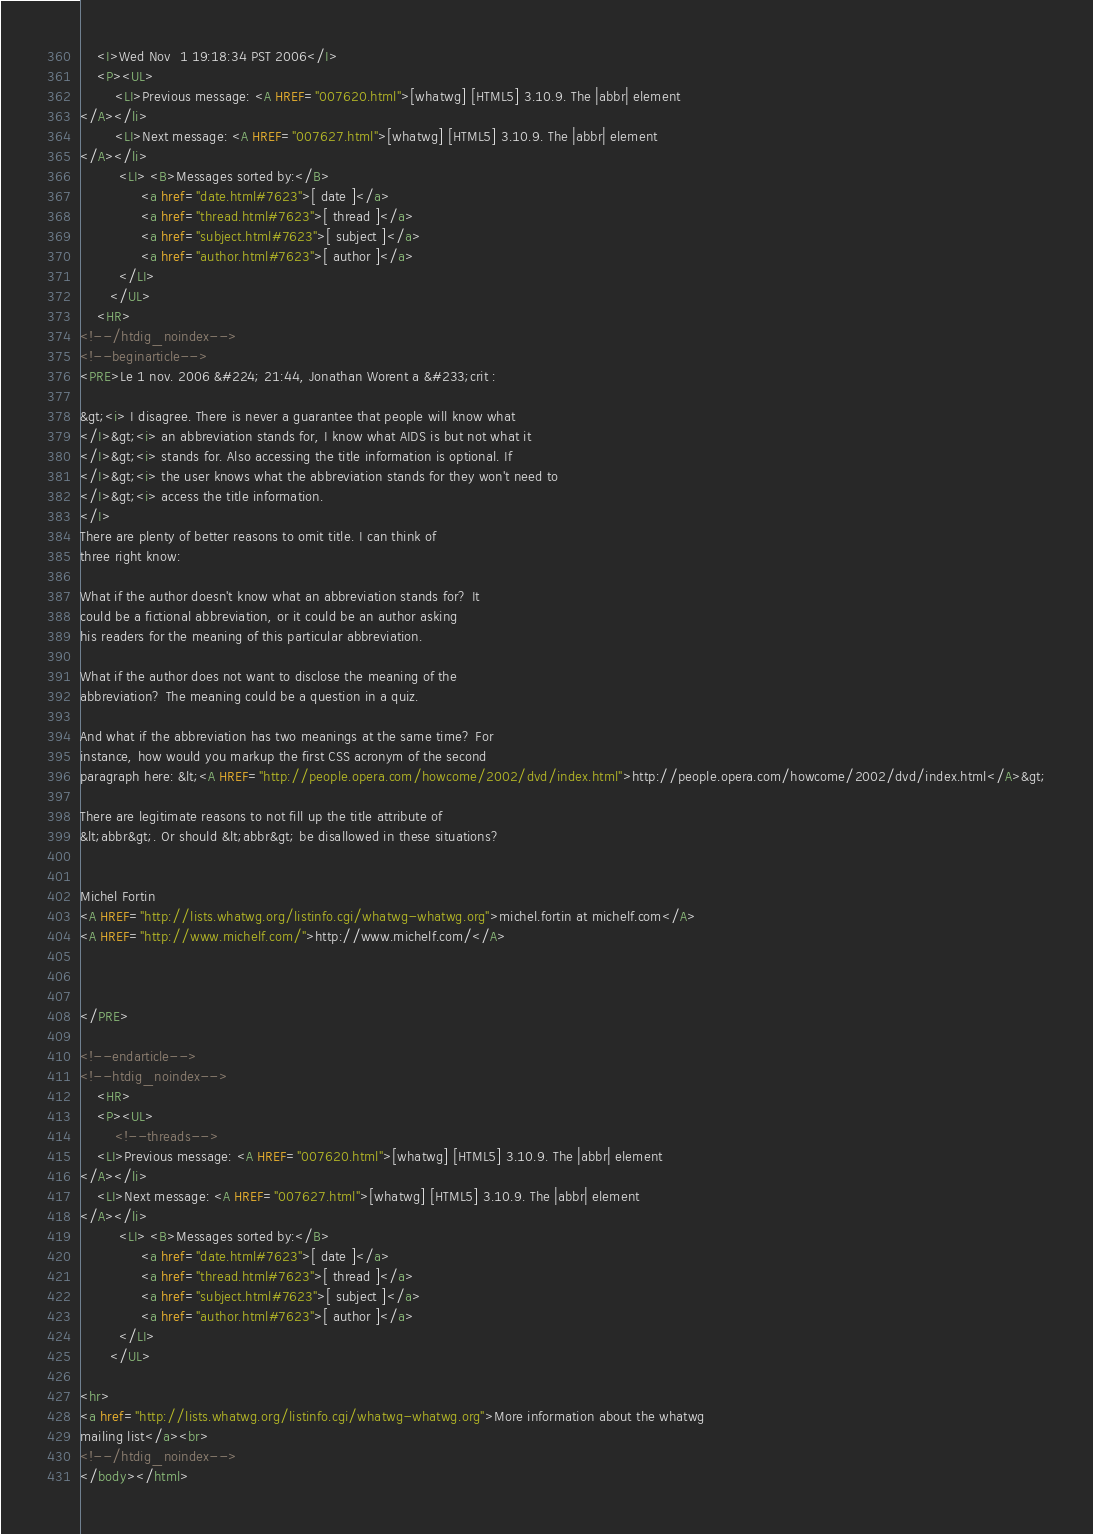<code> <loc_0><loc_0><loc_500><loc_500><_HTML_>    <I>Wed Nov  1 19:18:34 PST 2006</I>
    <P><UL>
        <LI>Previous message: <A HREF="007620.html">[whatwg] [HTML5] 3.10.9. The |abbr| element
</A></li>
        <LI>Next message: <A HREF="007627.html">[whatwg] [HTML5] 3.10.9. The |abbr| element
</A></li>
         <LI> <B>Messages sorted by:</B> 
              <a href="date.html#7623">[ date ]</a>
              <a href="thread.html#7623">[ thread ]</a>
              <a href="subject.html#7623">[ subject ]</a>
              <a href="author.html#7623">[ author ]</a>
         </LI>
       </UL>
    <HR>  
<!--/htdig_noindex-->
<!--beginarticle-->
<PRE>Le 1 nov. 2006 &#224; 21:44, Jonathan Worent a &#233;crit :

&gt;<i> I disagree. There is never a guarantee that people will know what  
</I>&gt;<i> an abbreviation stands for, I know what AIDS is but not what it  
</I>&gt;<i> stands for. Also accessing the title information is optional. If  
</I>&gt;<i> the user knows what the abbreviation stands for they won't need to  
</I>&gt;<i> access the title information.
</I>
There are plenty of better reasons to omit title. I can think of  
three right know:

What if the author doesn't know what an abbreviation stands for? It  
could be a fictional abbreviation, or it could be an author asking  
his readers for the meaning of this particular abbreviation.

What if the author does not want to disclose the meaning of the  
abbreviation? The meaning could be a question in a quiz.

And what if the abbreviation has two meanings at the same time? For  
instance, how would you markup the first CSS acronym of the second  
paragraph here: &lt;<A HREF="http://people.opera.com/howcome/2002/dvd/index.html">http://people.opera.com/howcome/2002/dvd/index.html</A>&gt;

There are legitimate reasons to not fill up the title attribute of  
&lt;abbr&gt;. Or should &lt;abbr&gt; be disallowed in these situations?


Michel Fortin
<A HREF="http://lists.whatwg.org/listinfo.cgi/whatwg-whatwg.org">michel.fortin at michelf.com</A>
<A HREF="http://www.michelf.com/">http://www.michelf.com/</A>



</PRE>

<!--endarticle-->
<!--htdig_noindex-->
    <HR>
    <P><UL>
        <!--threads-->
	<LI>Previous message: <A HREF="007620.html">[whatwg] [HTML5] 3.10.9. The |abbr| element
</A></li>
	<LI>Next message: <A HREF="007627.html">[whatwg] [HTML5] 3.10.9. The |abbr| element
</A></li>
         <LI> <B>Messages sorted by:</B> 
              <a href="date.html#7623">[ date ]</a>
              <a href="thread.html#7623">[ thread ]</a>
              <a href="subject.html#7623">[ subject ]</a>
              <a href="author.html#7623">[ author ]</a>
         </LI>
       </UL>

<hr>
<a href="http://lists.whatwg.org/listinfo.cgi/whatwg-whatwg.org">More information about the whatwg
mailing list</a><br>
<!--/htdig_noindex-->
</body></html>
</code> 